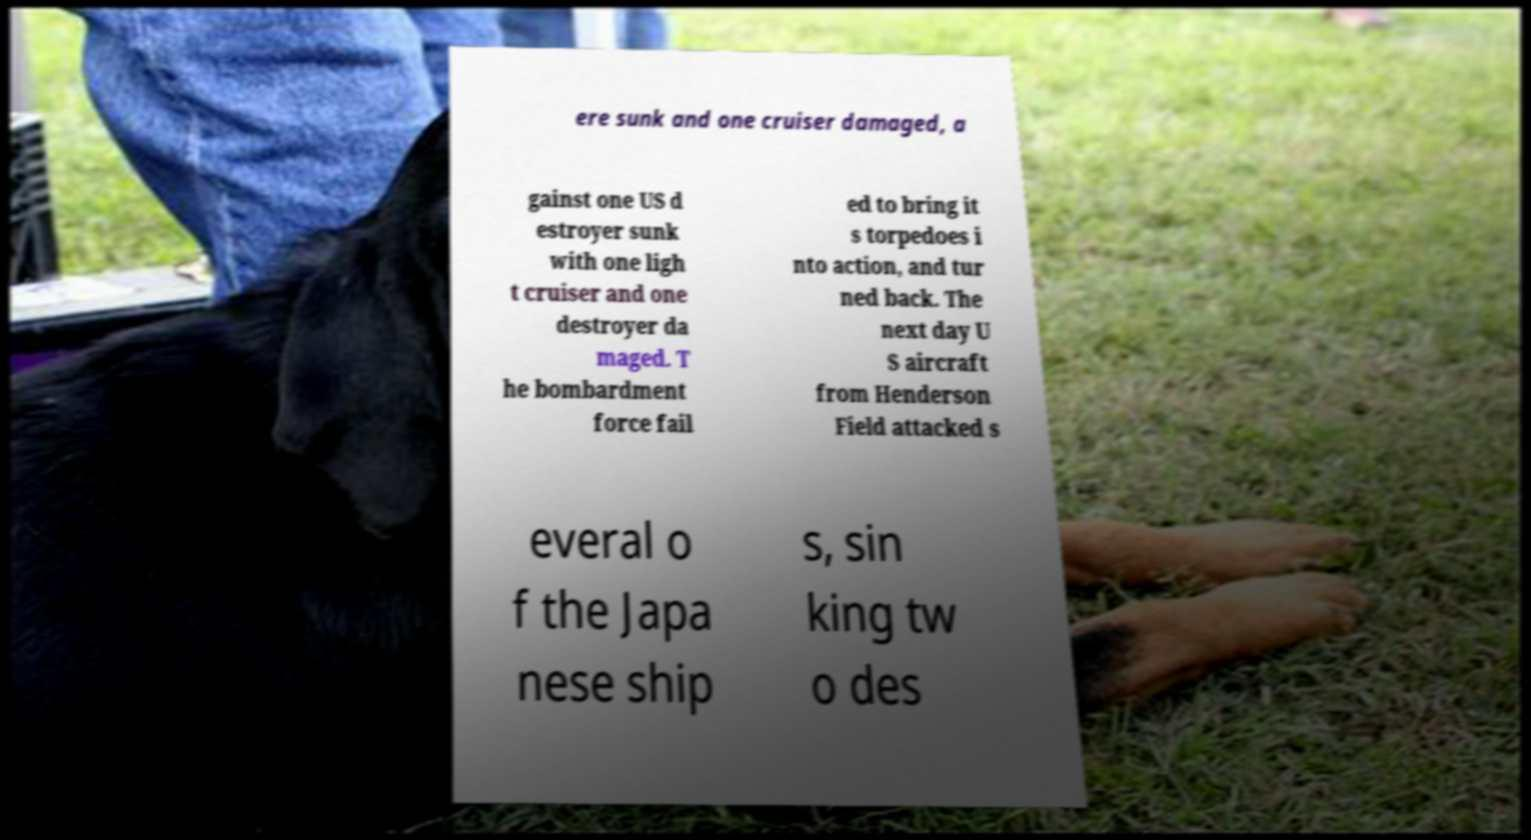Could you assist in decoding the text presented in this image and type it out clearly? ere sunk and one cruiser damaged, a gainst one US d estroyer sunk with one ligh t cruiser and one destroyer da maged. T he bombardment force fail ed to bring it s torpedoes i nto action, and tur ned back. The next day U S aircraft from Henderson Field attacked s everal o f the Japa nese ship s, sin king tw o des 